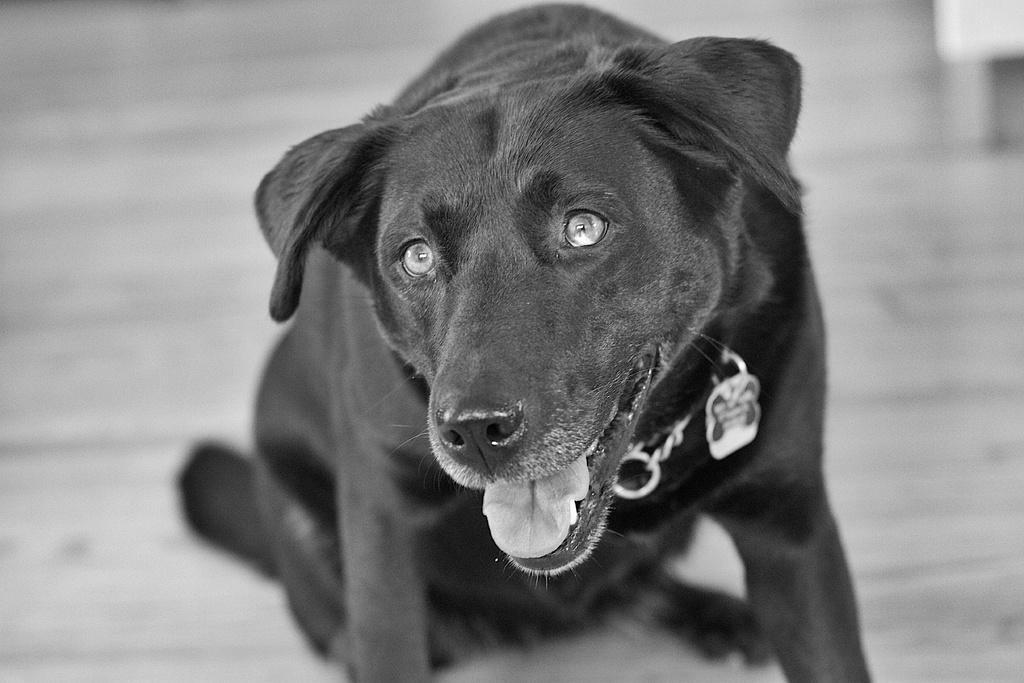Can you describe this image briefly? In the picture we can see a dog sitting on the floor which is black in color and to its neck we can see a chain and locket. 